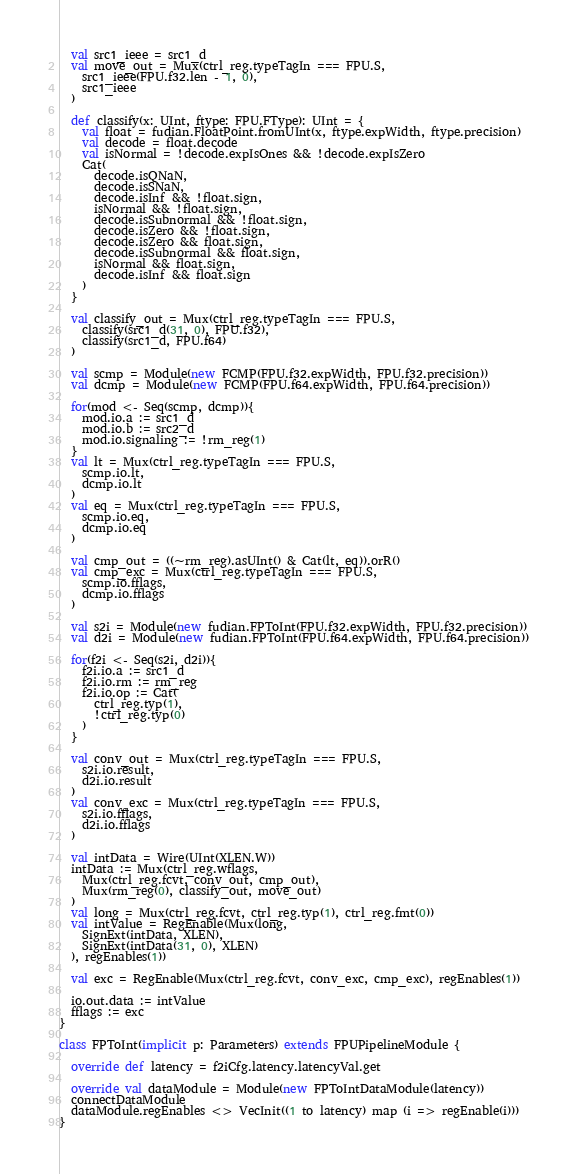Convert code to text. <code><loc_0><loc_0><loc_500><loc_500><_Scala_>  val src1_ieee = src1_d
  val move_out = Mux(ctrl_reg.typeTagIn === FPU.S,
    src1_ieee(FPU.f32.len - 1, 0),
    src1_ieee
  )

  def classify(x: UInt, ftype: FPU.FType): UInt = {
    val float = fudian.FloatPoint.fromUInt(x, ftype.expWidth, ftype.precision)
    val decode = float.decode
    val isNormal = !decode.expIsOnes && !decode.expIsZero
    Cat(
      decode.isQNaN,
      decode.isSNaN,
      decode.isInf && !float.sign,
      isNormal && !float.sign,
      decode.isSubnormal && !float.sign,
      decode.isZero && !float.sign,
      decode.isZero && float.sign,
      decode.isSubnormal && float.sign,
      isNormal && float.sign,
      decode.isInf && float.sign
    )
  }

  val classify_out = Mux(ctrl_reg.typeTagIn === FPU.S,
    classify(src1_d(31, 0), FPU.f32),
    classify(src1_d, FPU.f64)
  )

  val scmp = Module(new FCMP(FPU.f32.expWidth, FPU.f32.precision))
  val dcmp = Module(new FCMP(FPU.f64.expWidth, FPU.f64.precision))

  for(mod <- Seq(scmp, dcmp)){
    mod.io.a := src1_d
    mod.io.b := src2_d
    mod.io.signaling := !rm_reg(1)
  }
  val lt = Mux(ctrl_reg.typeTagIn === FPU.S,
    scmp.io.lt,
    dcmp.io.lt
  )
  val eq = Mux(ctrl_reg.typeTagIn === FPU.S,
    scmp.io.eq,
    dcmp.io.eq
  )

  val cmp_out = ((~rm_reg).asUInt() & Cat(lt, eq)).orR()
  val cmp_exc = Mux(ctrl_reg.typeTagIn === FPU.S,
    scmp.io.fflags,
    dcmp.io.fflags
  )

  val s2i = Module(new fudian.FPToInt(FPU.f32.expWidth, FPU.f32.precision))
  val d2i = Module(new fudian.FPToInt(FPU.f64.expWidth, FPU.f64.precision))

  for(f2i <- Seq(s2i, d2i)){
    f2i.io.a := src1_d
    f2i.io.rm := rm_reg
    f2i.io.op := Cat(
      ctrl_reg.typ(1),
      !ctrl_reg.typ(0)
    )
  }

  val conv_out = Mux(ctrl_reg.typeTagIn === FPU.S,
    s2i.io.result,
    d2i.io.result
  )
  val conv_exc = Mux(ctrl_reg.typeTagIn === FPU.S,
    s2i.io.fflags,
    d2i.io.fflags
  )

  val intData = Wire(UInt(XLEN.W))
  intData := Mux(ctrl_reg.wflags,
    Mux(ctrl_reg.fcvt, conv_out, cmp_out),
    Mux(rm_reg(0), classify_out, move_out)
  )
  val long = Mux(ctrl_reg.fcvt, ctrl_reg.typ(1), ctrl_reg.fmt(0))
  val intValue = RegEnable(Mux(long,
    SignExt(intData, XLEN),
    SignExt(intData(31, 0), XLEN)
  ), regEnables(1))

  val exc = RegEnable(Mux(ctrl_reg.fcvt, conv_exc, cmp_exc), regEnables(1))

  io.out.data := intValue
  fflags := exc
}

class FPToInt(implicit p: Parameters) extends FPUPipelineModule {

  override def latency = f2iCfg.latency.latencyVal.get

  override val dataModule = Module(new FPToIntDataModule(latency))
  connectDataModule
  dataModule.regEnables <> VecInit((1 to latency) map (i => regEnable(i)))
}
</code> 